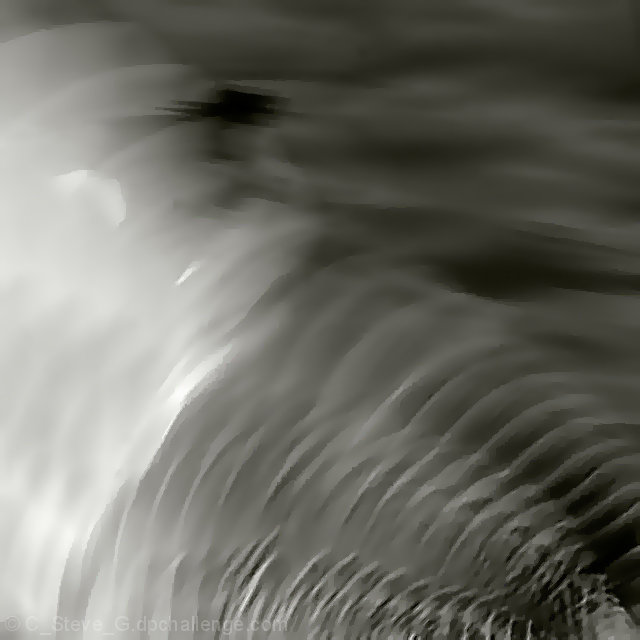Are there any obvious noise artifacts in the image? Upon close examination, the image maintains a high level of clarity with no readily apparent noise artifacts, suggesting that it has been well-captured or processed effectively to minimize such distractions. 